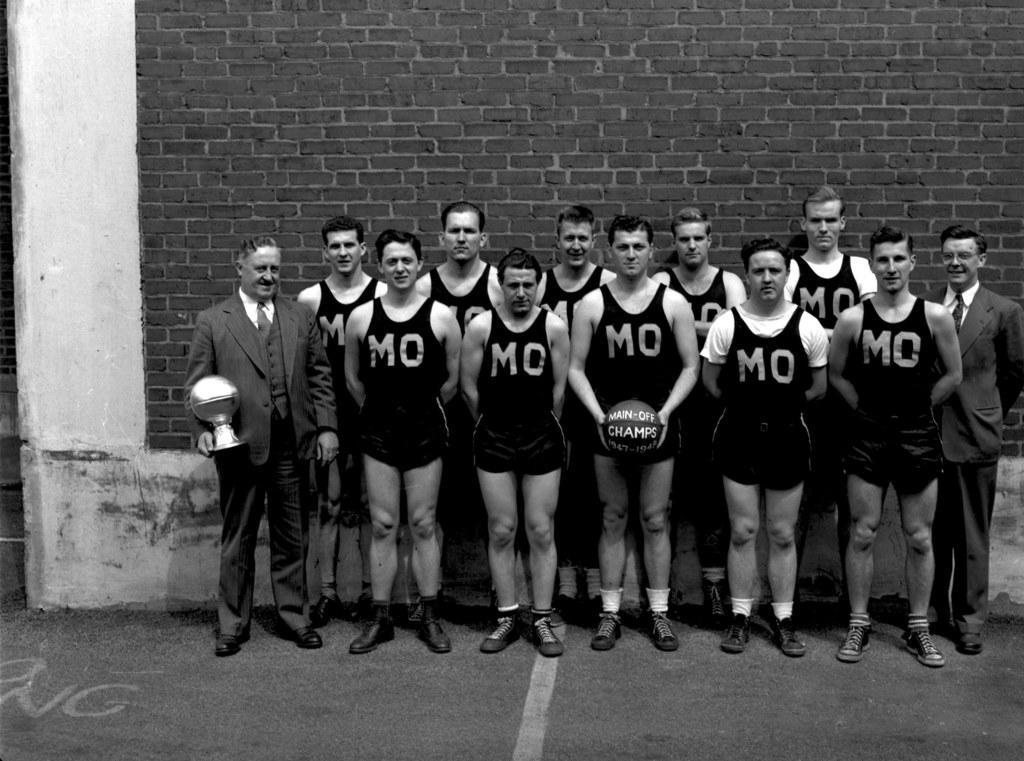How would you summarize this image in a sentence or two? In this image I can see there are few persons wearing a black color shirts standing on the floor, on the left side a person holding an object, in the middle a person holding a ball and at the top I can see the wall. 